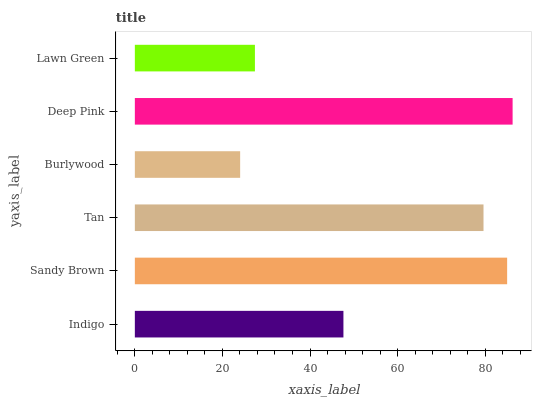Is Burlywood the minimum?
Answer yes or no. Yes. Is Deep Pink the maximum?
Answer yes or no. Yes. Is Sandy Brown the minimum?
Answer yes or no. No. Is Sandy Brown the maximum?
Answer yes or no. No. Is Sandy Brown greater than Indigo?
Answer yes or no. Yes. Is Indigo less than Sandy Brown?
Answer yes or no. Yes. Is Indigo greater than Sandy Brown?
Answer yes or no. No. Is Sandy Brown less than Indigo?
Answer yes or no. No. Is Tan the high median?
Answer yes or no. Yes. Is Indigo the low median?
Answer yes or no. Yes. Is Lawn Green the high median?
Answer yes or no. No. Is Burlywood the low median?
Answer yes or no. No. 